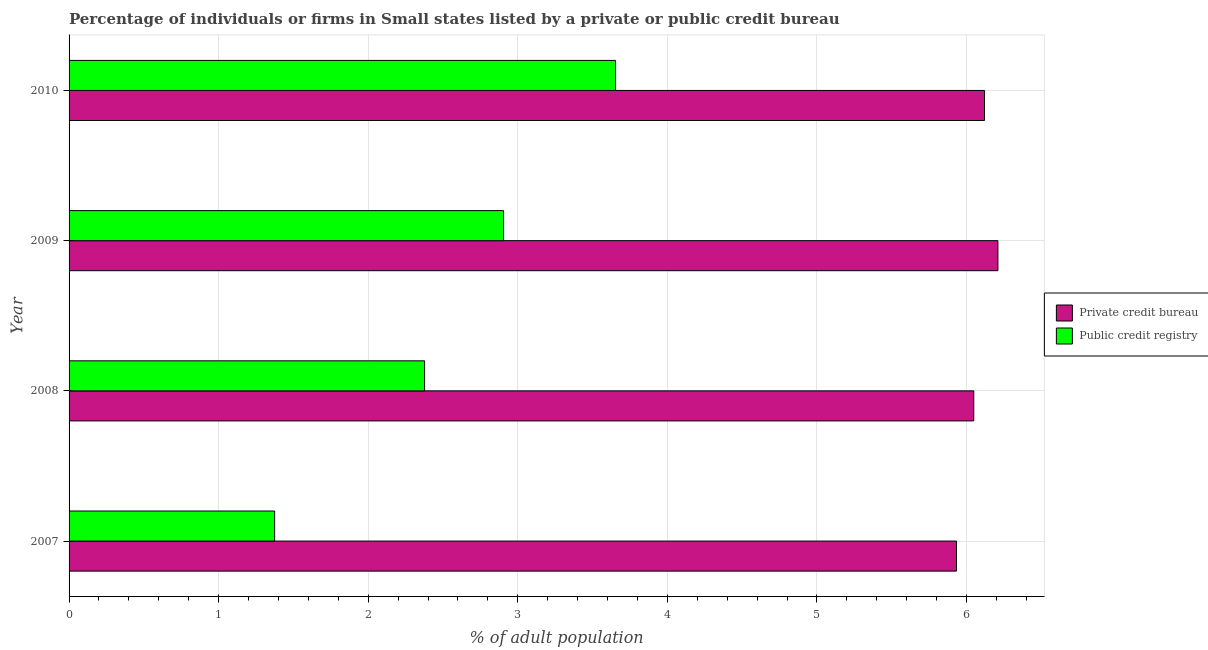How many groups of bars are there?
Your answer should be very brief. 4. Are the number of bars on each tick of the Y-axis equal?
Keep it short and to the point. Yes. How many bars are there on the 3rd tick from the bottom?
Ensure brevity in your answer.  2. What is the percentage of firms listed by public credit bureau in 2010?
Keep it short and to the point. 3.65. Across all years, what is the maximum percentage of firms listed by private credit bureau?
Keep it short and to the point. 6.21. Across all years, what is the minimum percentage of firms listed by private credit bureau?
Provide a succinct answer. 5.93. In which year was the percentage of firms listed by public credit bureau maximum?
Ensure brevity in your answer.  2010. What is the total percentage of firms listed by private credit bureau in the graph?
Give a very brief answer. 24.31. What is the difference between the percentage of firms listed by public credit bureau in 2007 and that in 2009?
Ensure brevity in your answer.  -1.53. What is the difference between the percentage of firms listed by public credit bureau in 2009 and the percentage of firms listed by private credit bureau in 2008?
Your answer should be very brief. -3.14. What is the average percentage of firms listed by private credit bureau per year?
Your answer should be compact. 6.08. In the year 2009, what is the difference between the percentage of firms listed by private credit bureau and percentage of firms listed by public credit bureau?
Ensure brevity in your answer.  3.31. In how many years, is the percentage of firms listed by private credit bureau greater than 5.6 %?
Offer a terse response. 4. What is the ratio of the percentage of firms listed by public credit bureau in 2007 to that in 2009?
Provide a short and direct response. 0.47. Is the percentage of firms listed by public credit bureau in 2007 less than that in 2010?
Your answer should be compact. Yes. Is the difference between the percentage of firms listed by private credit bureau in 2007 and 2008 greater than the difference between the percentage of firms listed by public credit bureau in 2007 and 2008?
Keep it short and to the point. Yes. What is the difference between the highest and the second highest percentage of firms listed by private credit bureau?
Your answer should be very brief. 0.09. What is the difference between the highest and the lowest percentage of firms listed by public credit bureau?
Provide a succinct answer. 2.28. What does the 1st bar from the top in 2010 represents?
Your response must be concise. Public credit registry. What does the 1st bar from the bottom in 2008 represents?
Your answer should be very brief. Private credit bureau. Are all the bars in the graph horizontal?
Give a very brief answer. Yes. Does the graph contain grids?
Your response must be concise. Yes. How many legend labels are there?
Ensure brevity in your answer.  2. What is the title of the graph?
Provide a succinct answer. Percentage of individuals or firms in Small states listed by a private or public credit bureau. Does "2012 US$" appear as one of the legend labels in the graph?
Offer a very short reply. No. What is the label or title of the X-axis?
Offer a terse response. % of adult population. What is the % of adult population of Private credit bureau in 2007?
Keep it short and to the point. 5.93. What is the % of adult population of Public credit registry in 2007?
Provide a short and direct response. 1.37. What is the % of adult population in Private credit bureau in 2008?
Offer a very short reply. 6.05. What is the % of adult population of Public credit registry in 2008?
Offer a very short reply. 2.38. What is the % of adult population of Private credit bureau in 2009?
Your answer should be very brief. 6.21. What is the % of adult population of Public credit registry in 2009?
Provide a succinct answer. 2.91. What is the % of adult population of Private credit bureau in 2010?
Provide a succinct answer. 6.12. What is the % of adult population in Public credit registry in 2010?
Your answer should be very brief. 3.65. Across all years, what is the maximum % of adult population in Private credit bureau?
Your answer should be compact. 6.21. Across all years, what is the maximum % of adult population in Public credit registry?
Your answer should be compact. 3.65. Across all years, what is the minimum % of adult population of Private credit bureau?
Your answer should be compact. 5.93. Across all years, what is the minimum % of adult population in Public credit registry?
Offer a terse response. 1.37. What is the total % of adult population of Private credit bureau in the graph?
Your answer should be compact. 24.31. What is the total % of adult population in Public credit registry in the graph?
Your response must be concise. 10.31. What is the difference between the % of adult population in Private credit bureau in 2007 and that in 2008?
Provide a short and direct response. -0.12. What is the difference between the % of adult population in Public credit registry in 2007 and that in 2008?
Your response must be concise. -1. What is the difference between the % of adult population in Private credit bureau in 2007 and that in 2009?
Your answer should be very brief. -0.28. What is the difference between the % of adult population in Public credit registry in 2007 and that in 2009?
Offer a very short reply. -1.53. What is the difference between the % of adult population of Private credit bureau in 2007 and that in 2010?
Your response must be concise. -0.19. What is the difference between the % of adult population of Public credit registry in 2007 and that in 2010?
Your answer should be compact. -2.28. What is the difference between the % of adult population in Private credit bureau in 2008 and that in 2009?
Offer a very short reply. -0.16. What is the difference between the % of adult population in Public credit registry in 2008 and that in 2009?
Your answer should be compact. -0.53. What is the difference between the % of adult population of Private credit bureau in 2008 and that in 2010?
Make the answer very short. -0.07. What is the difference between the % of adult population of Public credit registry in 2008 and that in 2010?
Ensure brevity in your answer.  -1.28. What is the difference between the % of adult population of Private credit bureau in 2009 and that in 2010?
Offer a very short reply. 0.09. What is the difference between the % of adult population of Public credit registry in 2009 and that in 2010?
Provide a succinct answer. -0.75. What is the difference between the % of adult population in Private credit bureau in 2007 and the % of adult population in Public credit registry in 2008?
Your response must be concise. 3.56. What is the difference between the % of adult population of Private credit bureau in 2007 and the % of adult population of Public credit registry in 2009?
Make the answer very short. 3.03. What is the difference between the % of adult population in Private credit bureau in 2007 and the % of adult population in Public credit registry in 2010?
Ensure brevity in your answer.  2.28. What is the difference between the % of adult population of Private credit bureau in 2008 and the % of adult population of Public credit registry in 2009?
Give a very brief answer. 3.14. What is the difference between the % of adult population of Private credit bureau in 2008 and the % of adult population of Public credit registry in 2010?
Give a very brief answer. 2.39. What is the difference between the % of adult population in Private credit bureau in 2009 and the % of adult population in Public credit registry in 2010?
Offer a terse response. 2.56. What is the average % of adult population in Private credit bureau per year?
Your answer should be compact. 6.08. What is the average % of adult population of Public credit registry per year?
Provide a succinct answer. 2.58. In the year 2007, what is the difference between the % of adult population in Private credit bureau and % of adult population in Public credit registry?
Your answer should be very brief. 4.56. In the year 2008, what is the difference between the % of adult population in Private credit bureau and % of adult population in Public credit registry?
Your response must be concise. 3.67. In the year 2009, what is the difference between the % of adult population in Private credit bureau and % of adult population in Public credit registry?
Make the answer very short. 3.31. In the year 2010, what is the difference between the % of adult population of Private credit bureau and % of adult population of Public credit registry?
Your answer should be compact. 2.47. What is the ratio of the % of adult population in Private credit bureau in 2007 to that in 2008?
Ensure brevity in your answer.  0.98. What is the ratio of the % of adult population in Public credit registry in 2007 to that in 2008?
Offer a terse response. 0.58. What is the ratio of the % of adult population in Private credit bureau in 2007 to that in 2009?
Make the answer very short. 0.96. What is the ratio of the % of adult population of Public credit registry in 2007 to that in 2009?
Offer a very short reply. 0.47. What is the ratio of the % of adult population of Private credit bureau in 2007 to that in 2010?
Give a very brief answer. 0.97. What is the ratio of the % of adult population in Public credit registry in 2007 to that in 2010?
Keep it short and to the point. 0.38. What is the ratio of the % of adult population in Private credit bureau in 2008 to that in 2009?
Offer a very short reply. 0.97. What is the ratio of the % of adult population in Public credit registry in 2008 to that in 2009?
Give a very brief answer. 0.82. What is the ratio of the % of adult population of Private credit bureau in 2008 to that in 2010?
Your answer should be compact. 0.99. What is the ratio of the % of adult population in Public credit registry in 2008 to that in 2010?
Your answer should be very brief. 0.65. What is the ratio of the % of adult population of Private credit bureau in 2009 to that in 2010?
Keep it short and to the point. 1.01. What is the ratio of the % of adult population in Public credit registry in 2009 to that in 2010?
Provide a succinct answer. 0.8. What is the difference between the highest and the second highest % of adult population in Private credit bureau?
Give a very brief answer. 0.09. What is the difference between the highest and the second highest % of adult population of Public credit registry?
Ensure brevity in your answer.  0.75. What is the difference between the highest and the lowest % of adult population in Private credit bureau?
Your answer should be very brief. 0.28. What is the difference between the highest and the lowest % of adult population in Public credit registry?
Offer a terse response. 2.28. 